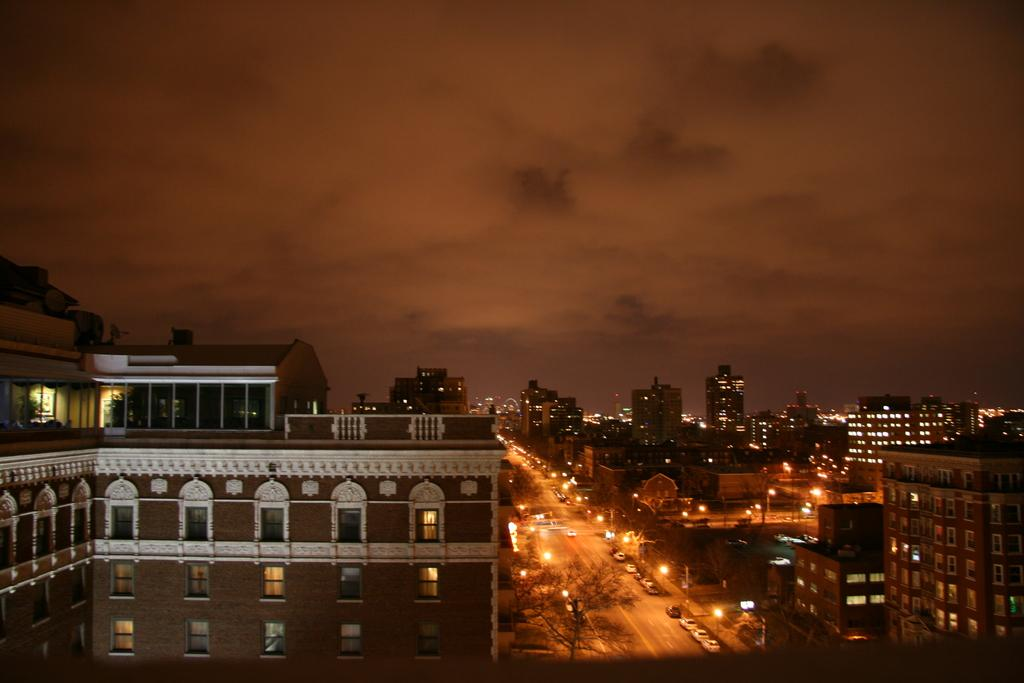What type of structures can be seen with lights in the image? There are buildings with lights in the image. What is moving on the road in the image? There are vehicles on the road in the image. What helps to illuminate the road in the image? Street lights are visible in the image. What can be seen in the distance in the image? Trees are present in the background of the image, and the sky is visible in the background of the image. How many apples are hanging from the power lines in the image? There are no apples or power lines present in the image. What is the mass of the vehicles on the road in the image? The mass of the vehicles cannot be determined from the image alone, as it depends on the specific vehicles and their weights. 